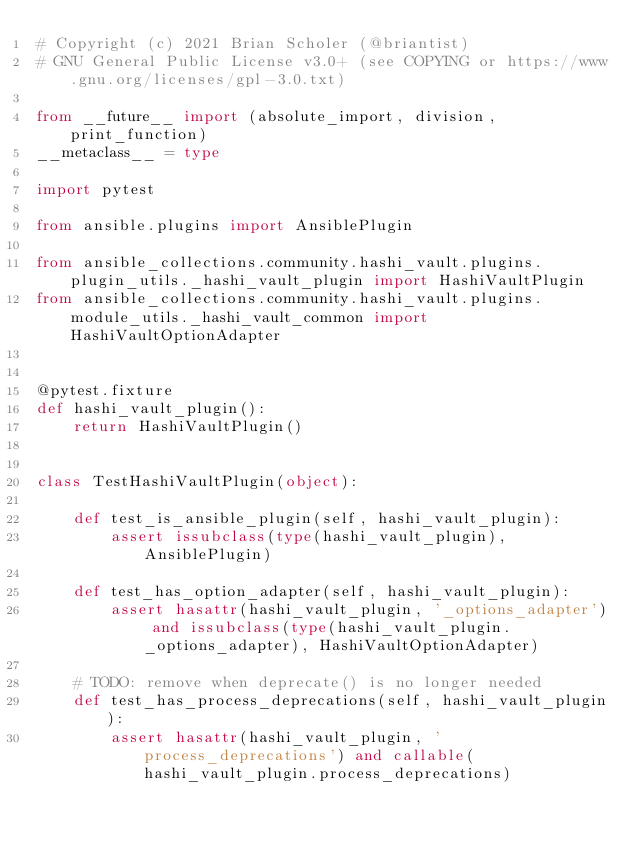Convert code to text. <code><loc_0><loc_0><loc_500><loc_500><_Python_># Copyright (c) 2021 Brian Scholer (@briantist)
# GNU General Public License v3.0+ (see COPYING or https://www.gnu.org/licenses/gpl-3.0.txt)

from __future__ import (absolute_import, division, print_function)
__metaclass__ = type

import pytest

from ansible.plugins import AnsiblePlugin

from ansible_collections.community.hashi_vault.plugins.plugin_utils._hashi_vault_plugin import HashiVaultPlugin
from ansible_collections.community.hashi_vault.plugins.module_utils._hashi_vault_common import HashiVaultOptionAdapter


@pytest.fixture
def hashi_vault_plugin():
    return HashiVaultPlugin()


class TestHashiVaultPlugin(object):

    def test_is_ansible_plugin(self, hashi_vault_plugin):
        assert issubclass(type(hashi_vault_plugin), AnsiblePlugin)

    def test_has_option_adapter(self, hashi_vault_plugin):
        assert hasattr(hashi_vault_plugin, '_options_adapter') and issubclass(type(hashi_vault_plugin._options_adapter), HashiVaultOptionAdapter)

    # TODO: remove when deprecate() is no longer needed
    def test_has_process_deprecations(self, hashi_vault_plugin):
        assert hasattr(hashi_vault_plugin, 'process_deprecations') and callable(hashi_vault_plugin.process_deprecations)
</code> 